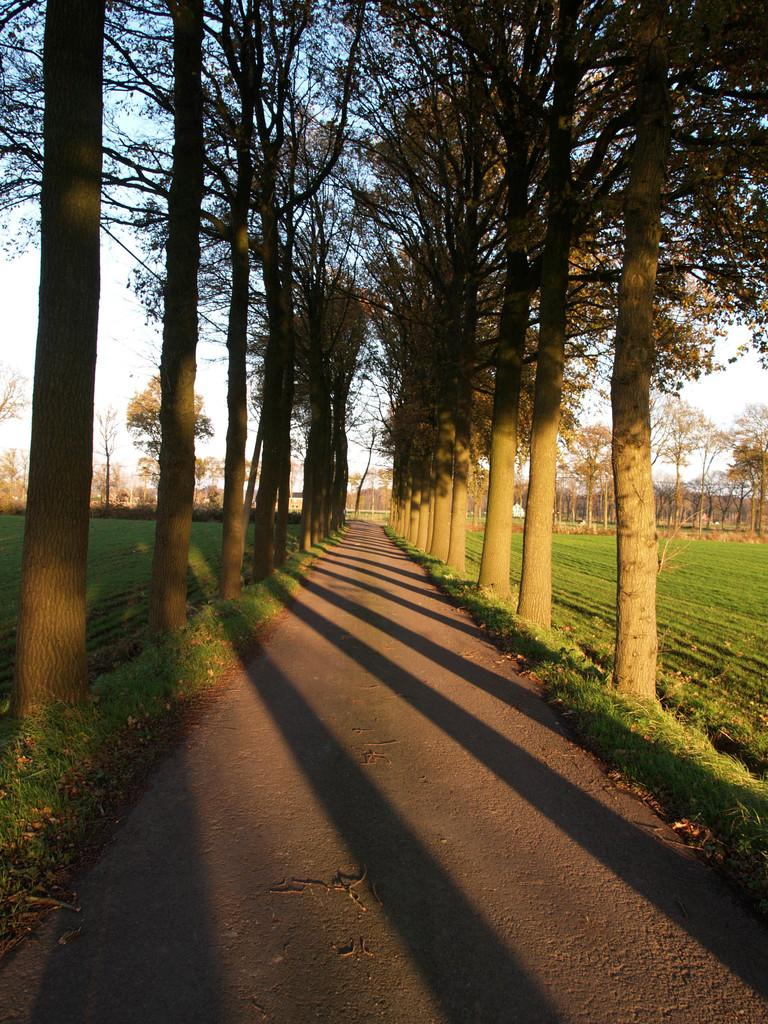What is the main subject of the image? The main subject of the image is a road. What can be seen on either side of the road? There are trees and fields on either side of the road. What type of wire can be seen hanging from the trees in the image? There is no wire hanging from the trees in the image. How many rolls of fabric can be seen in the fields in the image? There are no rolls of fabric present in the image. 